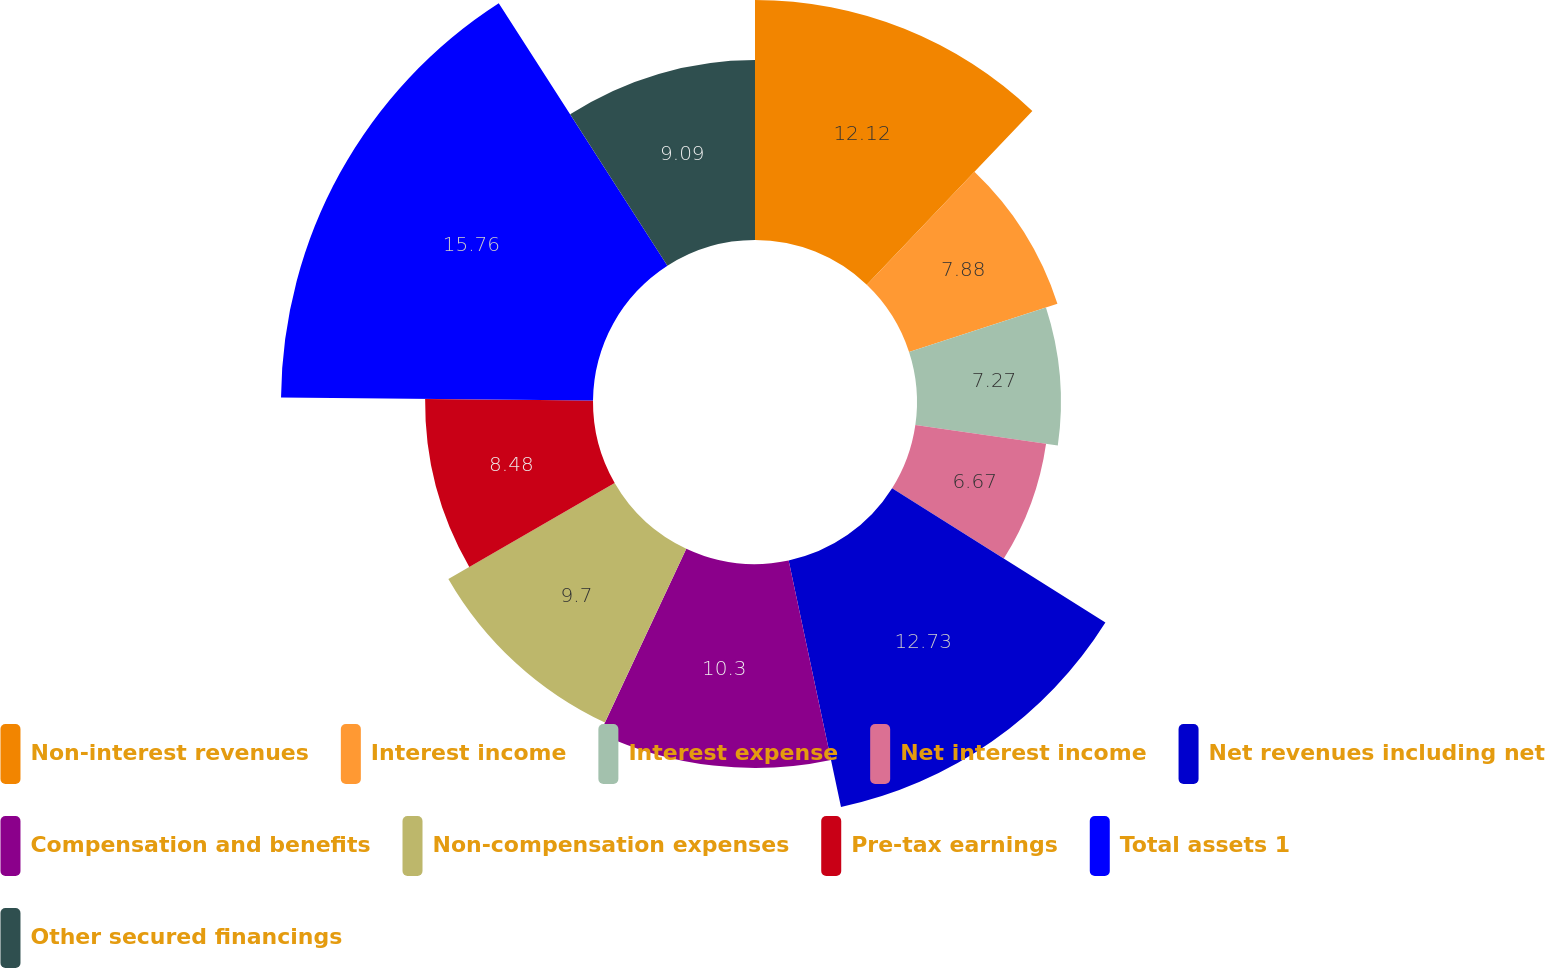<chart> <loc_0><loc_0><loc_500><loc_500><pie_chart><fcel>Non-interest revenues<fcel>Interest income<fcel>Interest expense<fcel>Net interest income<fcel>Net revenues including net<fcel>Compensation and benefits<fcel>Non-compensation expenses<fcel>Pre-tax earnings<fcel>Total assets 1<fcel>Other secured financings<nl><fcel>12.12%<fcel>7.88%<fcel>7.27%<fcel>6.67%<fcel>12.73%<fcel>10.3%<fcel>9.7%<fcel>8.48%<fcel>15.76%<fcel>9.09%<nl></chart> 